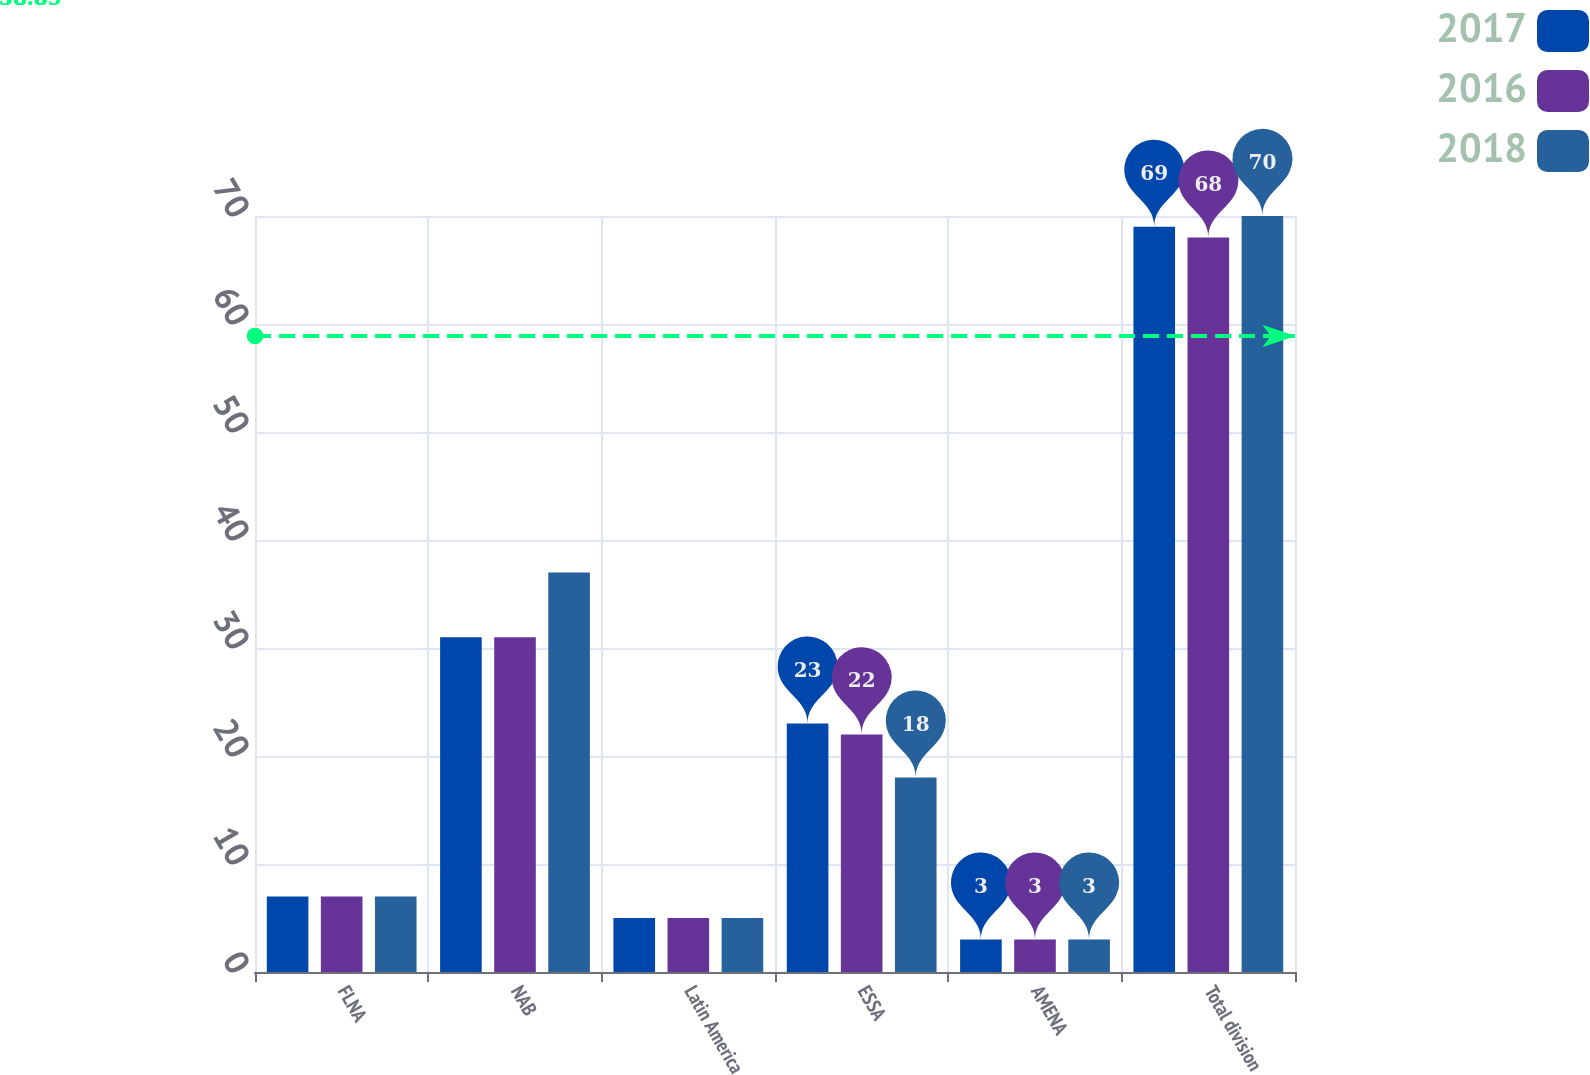Convert chart to OTSL. <chart><loc_0><loc_0><loc_500><loc_500><stacked_bar_chart><ecel><fcel>FLNA<fcel>NAB<fcel>Latin America<fcel>ESSA<fcel>AMENA<fcel>Total division<nl><fcel>2017<fcel>7<fcel>31<fcel>5<fcel>23<fcel>3<fcel>69<nl><fcel>2016<fcel>7<fcel>31<fcel>5<fcel>22<fcel>3<fcel>68<nl><fcel>2018<fcel>7<fcel>37<fcel>5<fcel>18<fcel>3<fcel>70<nl></chart> 